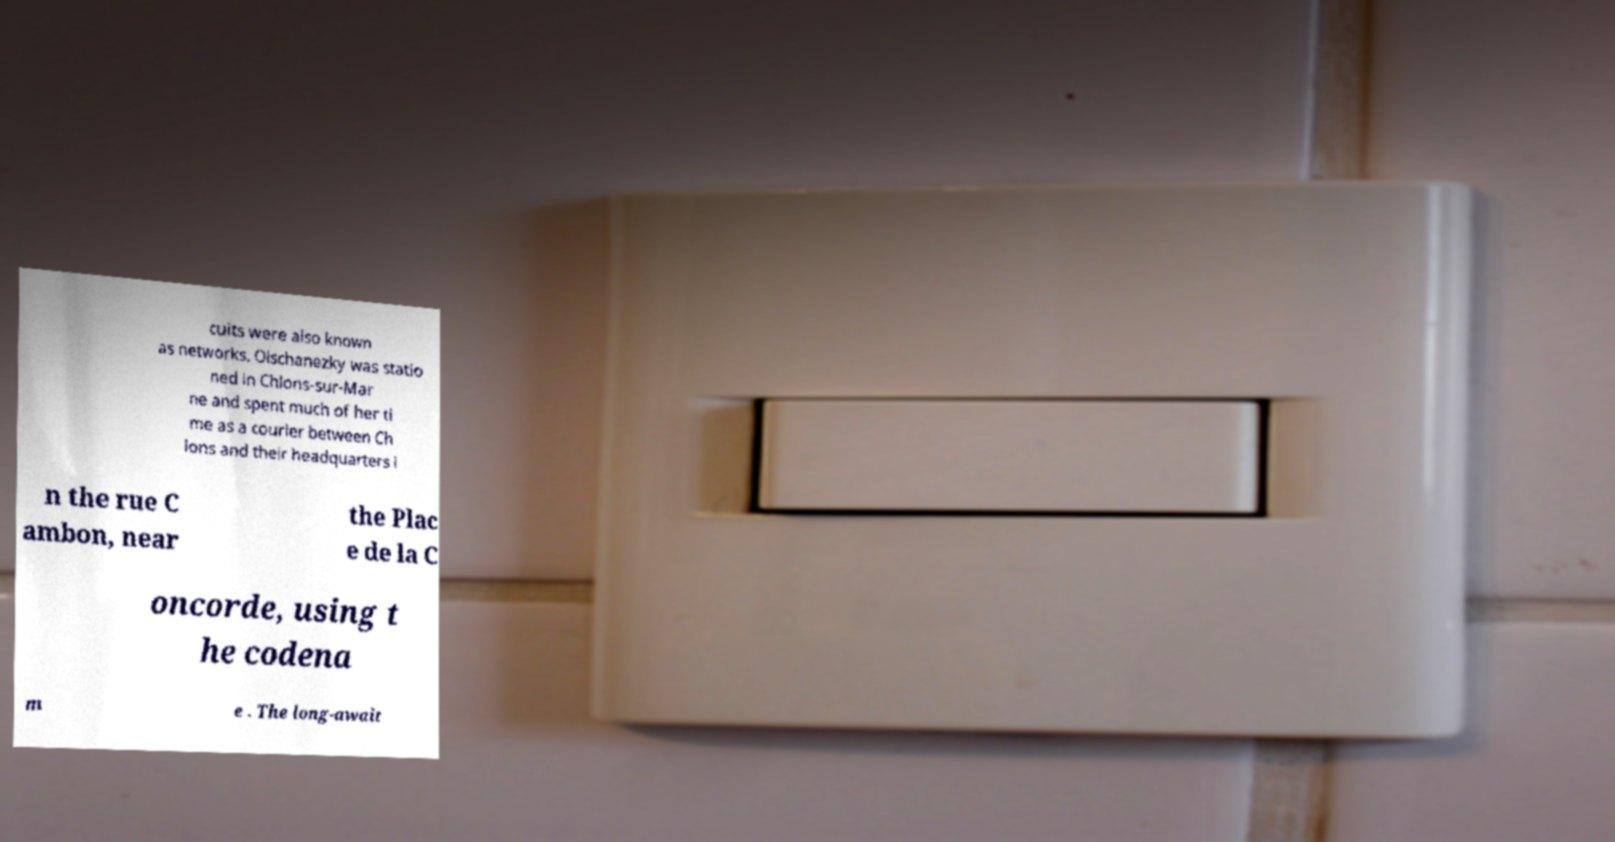For documentation purposes, I need the text within this image transcribed. Could you provide that? cuits were also known as networks. Olschanezky was statio ned in Chlons-sur-Mar ne and spent much of her ti me as a courier between Ch lons and their headquarters i n the rue C ambon, near the Plac e de la C oncorde, using t he codena m e . The long-await 